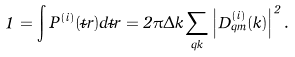<formula> <loc_0><loc_0><loc_500><loc_500>1 = \int P ^ { ( i ) } ( \vec { t } { r } ) d \vec { t } { r } = 2 \pi \Delta k \sum _ { q k } \left | D _ { q m } ^ { ( i ) } ( k ) \right | ^ { 2 } .</formula> 